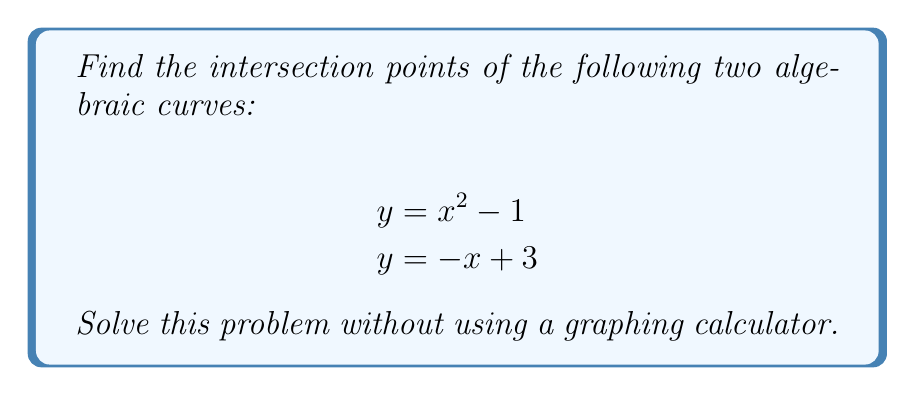Show me your answer to this math problem. To find the intersection points, we need to solve the system of equations:

$$y = x^2 - 1$$
$$y = -x + 3$$

Step 1: Set the equations equal to each other since they both equal y.
$$x^2 - 1 = -x + 3$$

Step 2: Rearrange the equation to standard form.
$$x^2 + x - 4 = 0$$

Step 3: Use the quadratic formula to solve for x.
$$x = \frac{-b \pm \sqrt{b^2 - 4ac}}{2a}$$

Where $a = 1$, $b = 1$, and $c = -4$

$$x = \frac{-1 \pm \sqrt{1^2 - 4(1)(-4)}}{2(1)}$$
$$x = \frac{-1 \pm \sqrt{17}}{2}$$

Step 4: Calculate the two x-values.
$$x_1 = \frac{-1 + \sqrt{17}}{2} \approx 1.56$$
$$x_2 = \frac{-1 - \sqrt{17}}{2} \approx -2.56$$

Step 5: Find the corresponding y-values by substituting the x-values into either of the original equations. Let's use $y = -x + 3$.

For $x_1$:
$$y_1 = -(\frac{-1 + \sqrt{17}}{2}) + 3 = \frac{7 - \sqrt{17}}{2} \approx 1.44$$

For $x_2$:
$$y_2 = -(\frac{-1 - \sqrt{17}}{2}) + 3 = \frac{7 + \sqrt{17}}{2} \approx 5.56$$

Therefore, the intersection points are $(\frac{-1 + \sqrt{17}}{2}, \frac{7 - \sqrt{17}}{2})$ and $(\frac{-1 - \sqrt{17}}{2}, \frac{7 + \sqrt{17}}{2})$.
Answer: $(\frac{-1 + \sqrt{17}}{2}, \frac{7 - \sqrt{17}}{2})$ and $(\frac{-1 - \sqrt{17}}{2}, \frac{7 + \sqrt{17}}{2})$ 